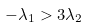Convert formula to latex. <formula><loc_0><loc_0><loc_500><loc_500>- \lambda _ { 1 } > 3 \lambda _ { 2 }</formula> 